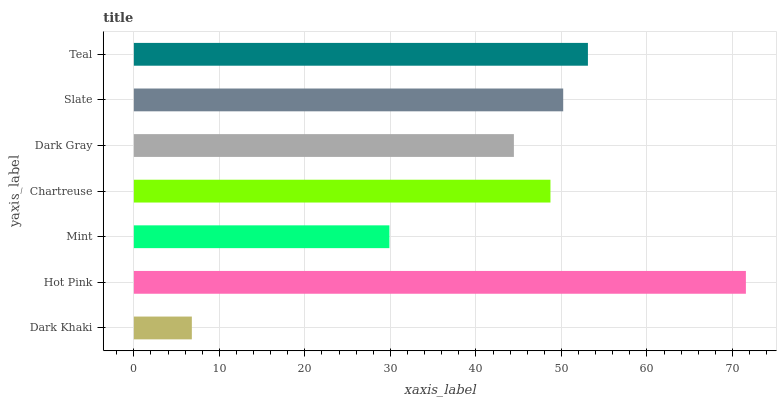Is Dark Khaki the minimum?
Answer yes or no. Yes. Is Hot Pink the maximum?
Answer yes or no. Yes. Is Mint the minimum?
Answer yes or no. No. Is Mint the maximum?
Answer yes or no. No. Is Hot Pink greater than Mint?
Answer yes or no. Yes. Is Mint less than Hot Pink?
Answer yes or no. Yes. Is Mint greater than Hot Pink?
Answer yes or no. No. Is Hot Pink less than Mint?
Answer yes or no. No. Is Chartreuse the high median?
Answer yes or no. Yes. Is Chartreuse the low median?
Answer yes or no. Yes. Is Dark Gray the high median?
Answer yes or no. No. Is Slate the low median?
Answer yes or no. No. 